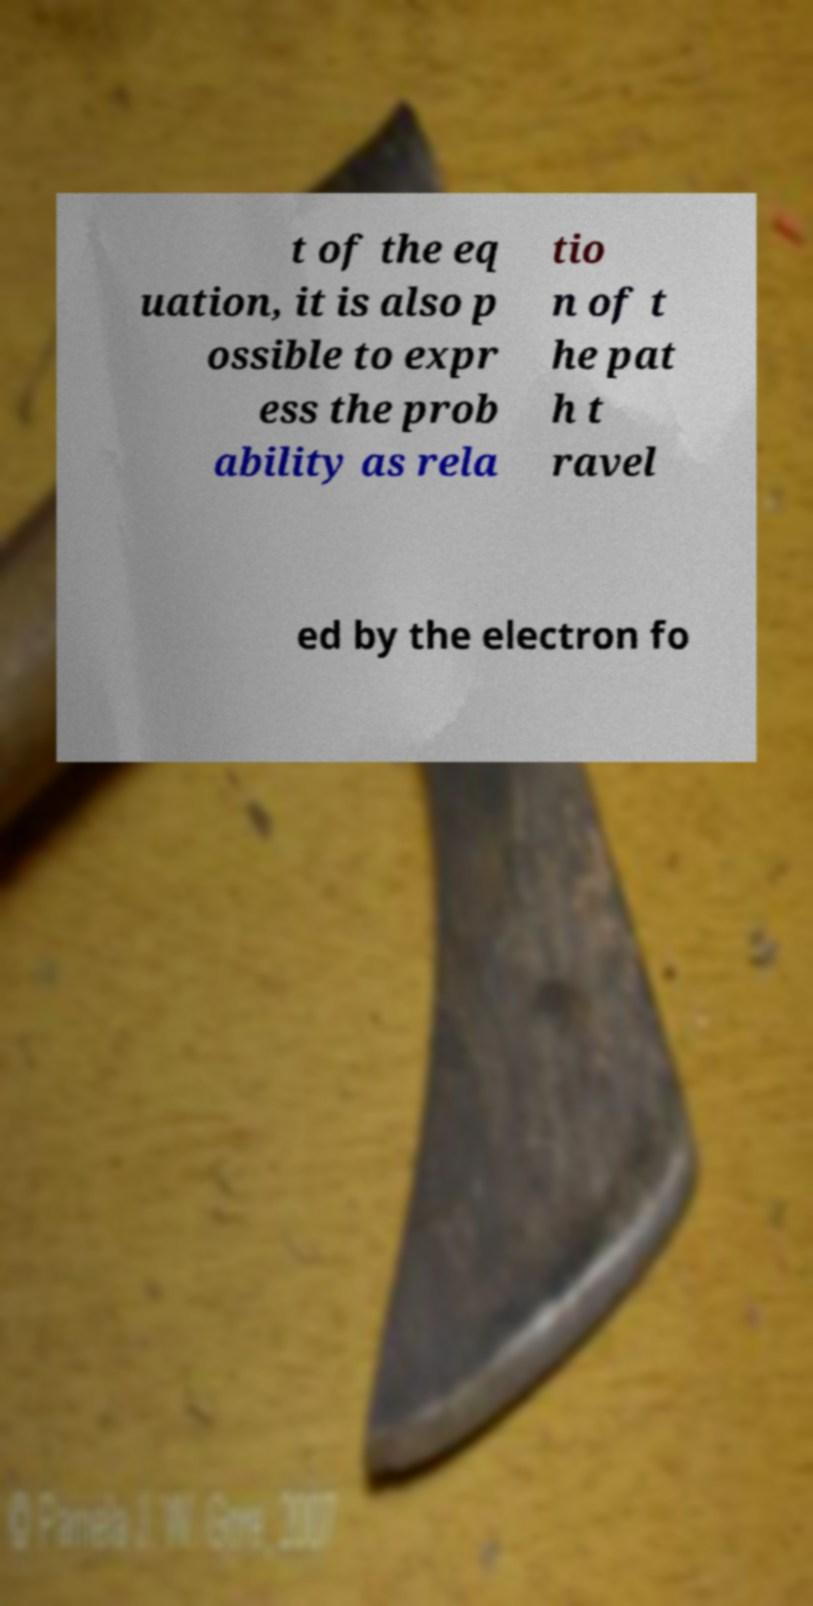There's text embedded in this image that I need extracted. Can you transcribe it verbatim? t of the eq uation, it is also p ossible to expr ess the prob ability as rela tio n of t he pat h t ravel ed by the electron fo 